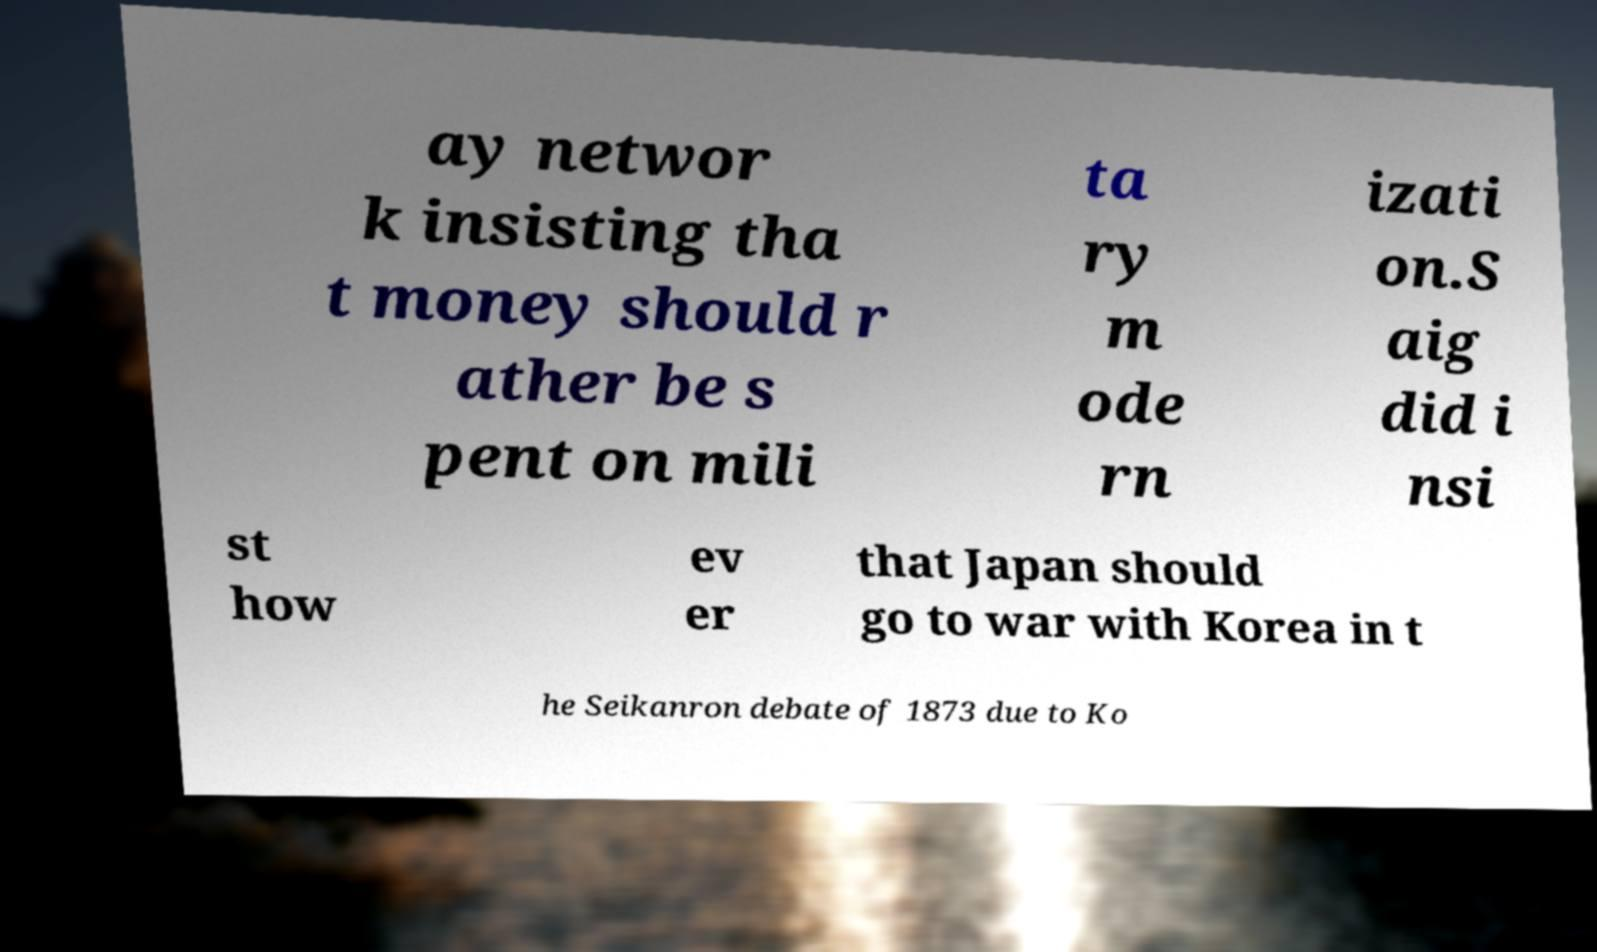Can you read and provide the text displayed in the image?This photo seems to have some interesting text. Can you extract and type it out for me? ay networ k insisting tha t money should r ather be s pent on mili ta ry m ode rn izati on.S aig did i nsi st how ev er that Japan should go to war with Korea in t he Seikanron debate of 1873 due to Ko 